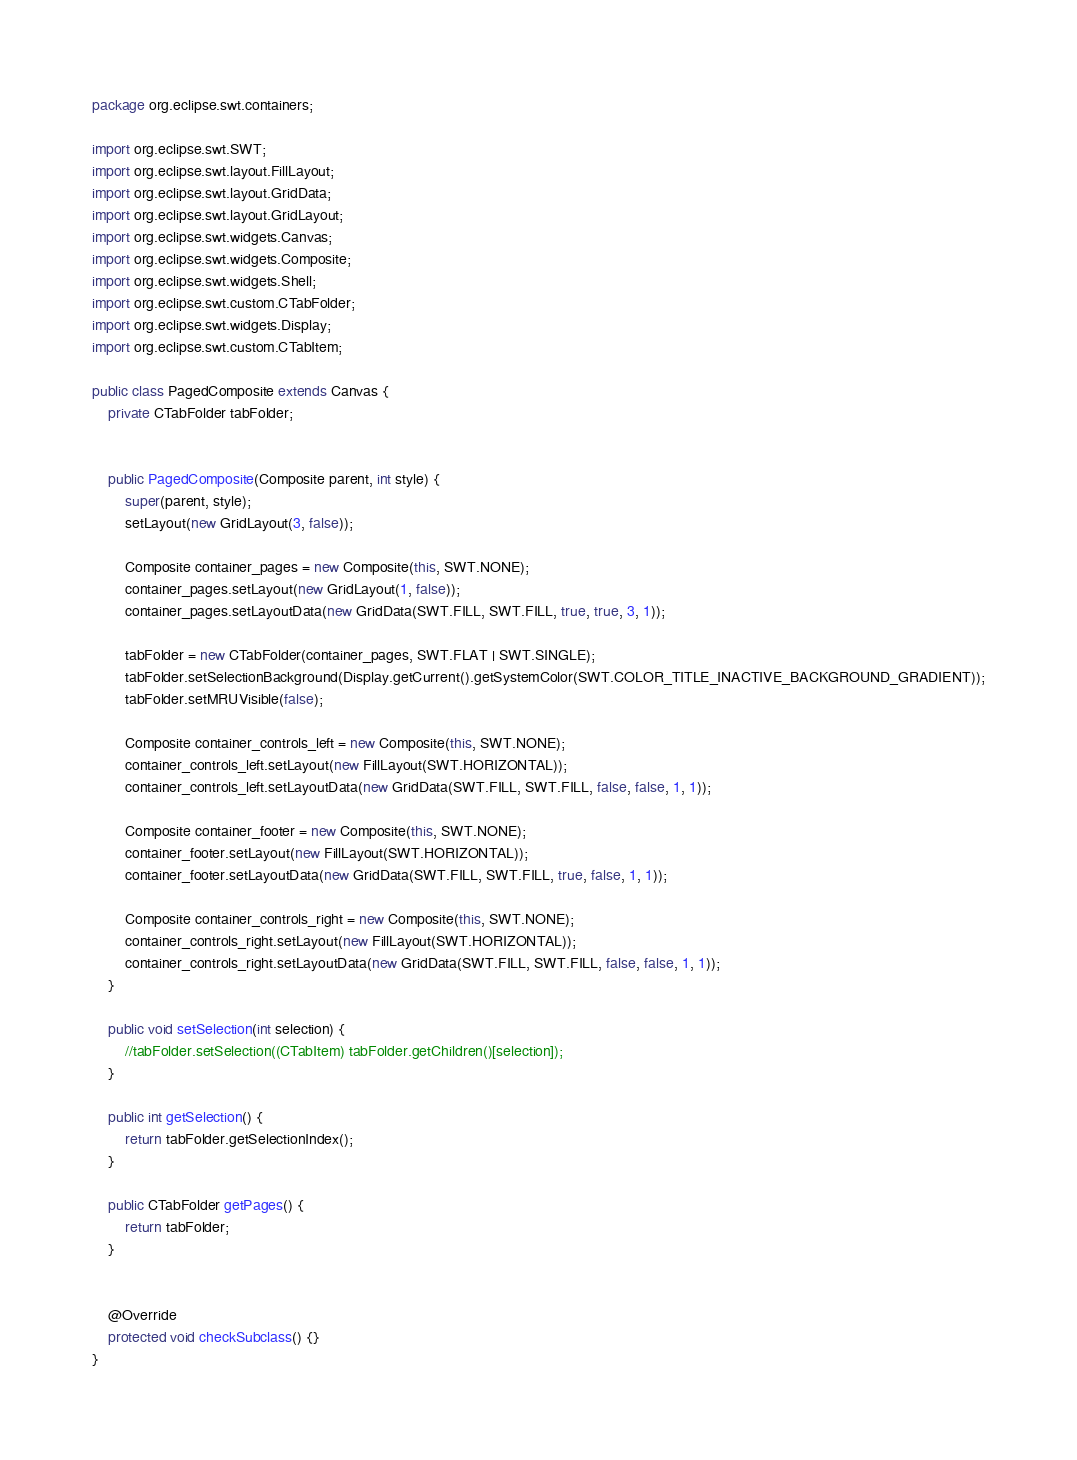<code> <loc_0><loc_0><loc_500><loc_500><_Java_>package org.eclipse.swt.containers;

import org.eclipse.swt.SWT;
import org.eclipse.swt.layout.FillLayout;
import org.eclipse.swt.layout.GridData;
import org.eclipse.swt.layout.GridLayout;
import org.eclipse.swt.widgets.Canvas;
import org.eclipse.swt.widgets.Composite;
import org.eclipse.swt.widgets.Shell;
import org.eclipse.swt.custom.CTabFolder;
import org.eclipse.swt.widgets.Display;
import org.eclipse.swt.custom.CTabItem;

public class PagedComposite extends Canvas {
	private CTabFolder tabFolder;

	
	public PagedComposite(Composite parent, int style) {
		super(parent, style);
		setLayout(new GridLayout(3, false));
		
		Composite container_pages = new Composite(this, SWT.NONE);
		container_pages.setLayout(new GridLayout(1, false));
		container_pages.setLayoutData(new GridData(SWT.FILL, SWT.FILL, true, true, 3, 1));
		
		tabFolder = new CTabFolder(container_pages, SWT.FLAT | SWT.SINGLE);
		tabFolder.setSelectionBackground(Display.getCurrent().getSystemColor(SWT.COLOR_TITLE_INACTIVE_BACKGROUND_GRADIENT));
		tabFolder.setMRUVisible(false);
		
		Composite container_controls_left = new Composite(this, SWT.NONE);
		container_controls_left.setLayout(new FillLayout(SWT.HORIZONTAL));
		container_controls_left.setLayoutData(new GridData(SWT.FILL, SWT.FILL, false, false, 1, 1));
		
		Composite container_footer = new Composite(this, SWT.NONE);
		container_footer.setLayout(new FillLayout(SWT.HORIZONTAL));
		container_footer.setLayoutData(new GridData(SWT.FILL, SWT.FILL, true, false, 1, 1));
		
		Composite container_controls_right = new Composite(this, SWT.NONE);
		container_controls_right.setLayout(new FillLayout(SWT.HORIZONTAL));
		container_controls_right.setLayoutData(new GridData(SWT.FILL, SWT.FILL, false, false, 1, 1));
	}
	
	public void setSelection(int selection) {
		//tabFolder.setSelection((CTabItem) tabFolder.getChildren()[selection]);
	}
	
	public int getSelection() {
		return tabFolder.getSelectionIndex();
	}
	
	public CTabFolder getPages() {
		return tabFolder;
	}
	

	@Override
	protected void checkSubclass() {}
}
</code> 